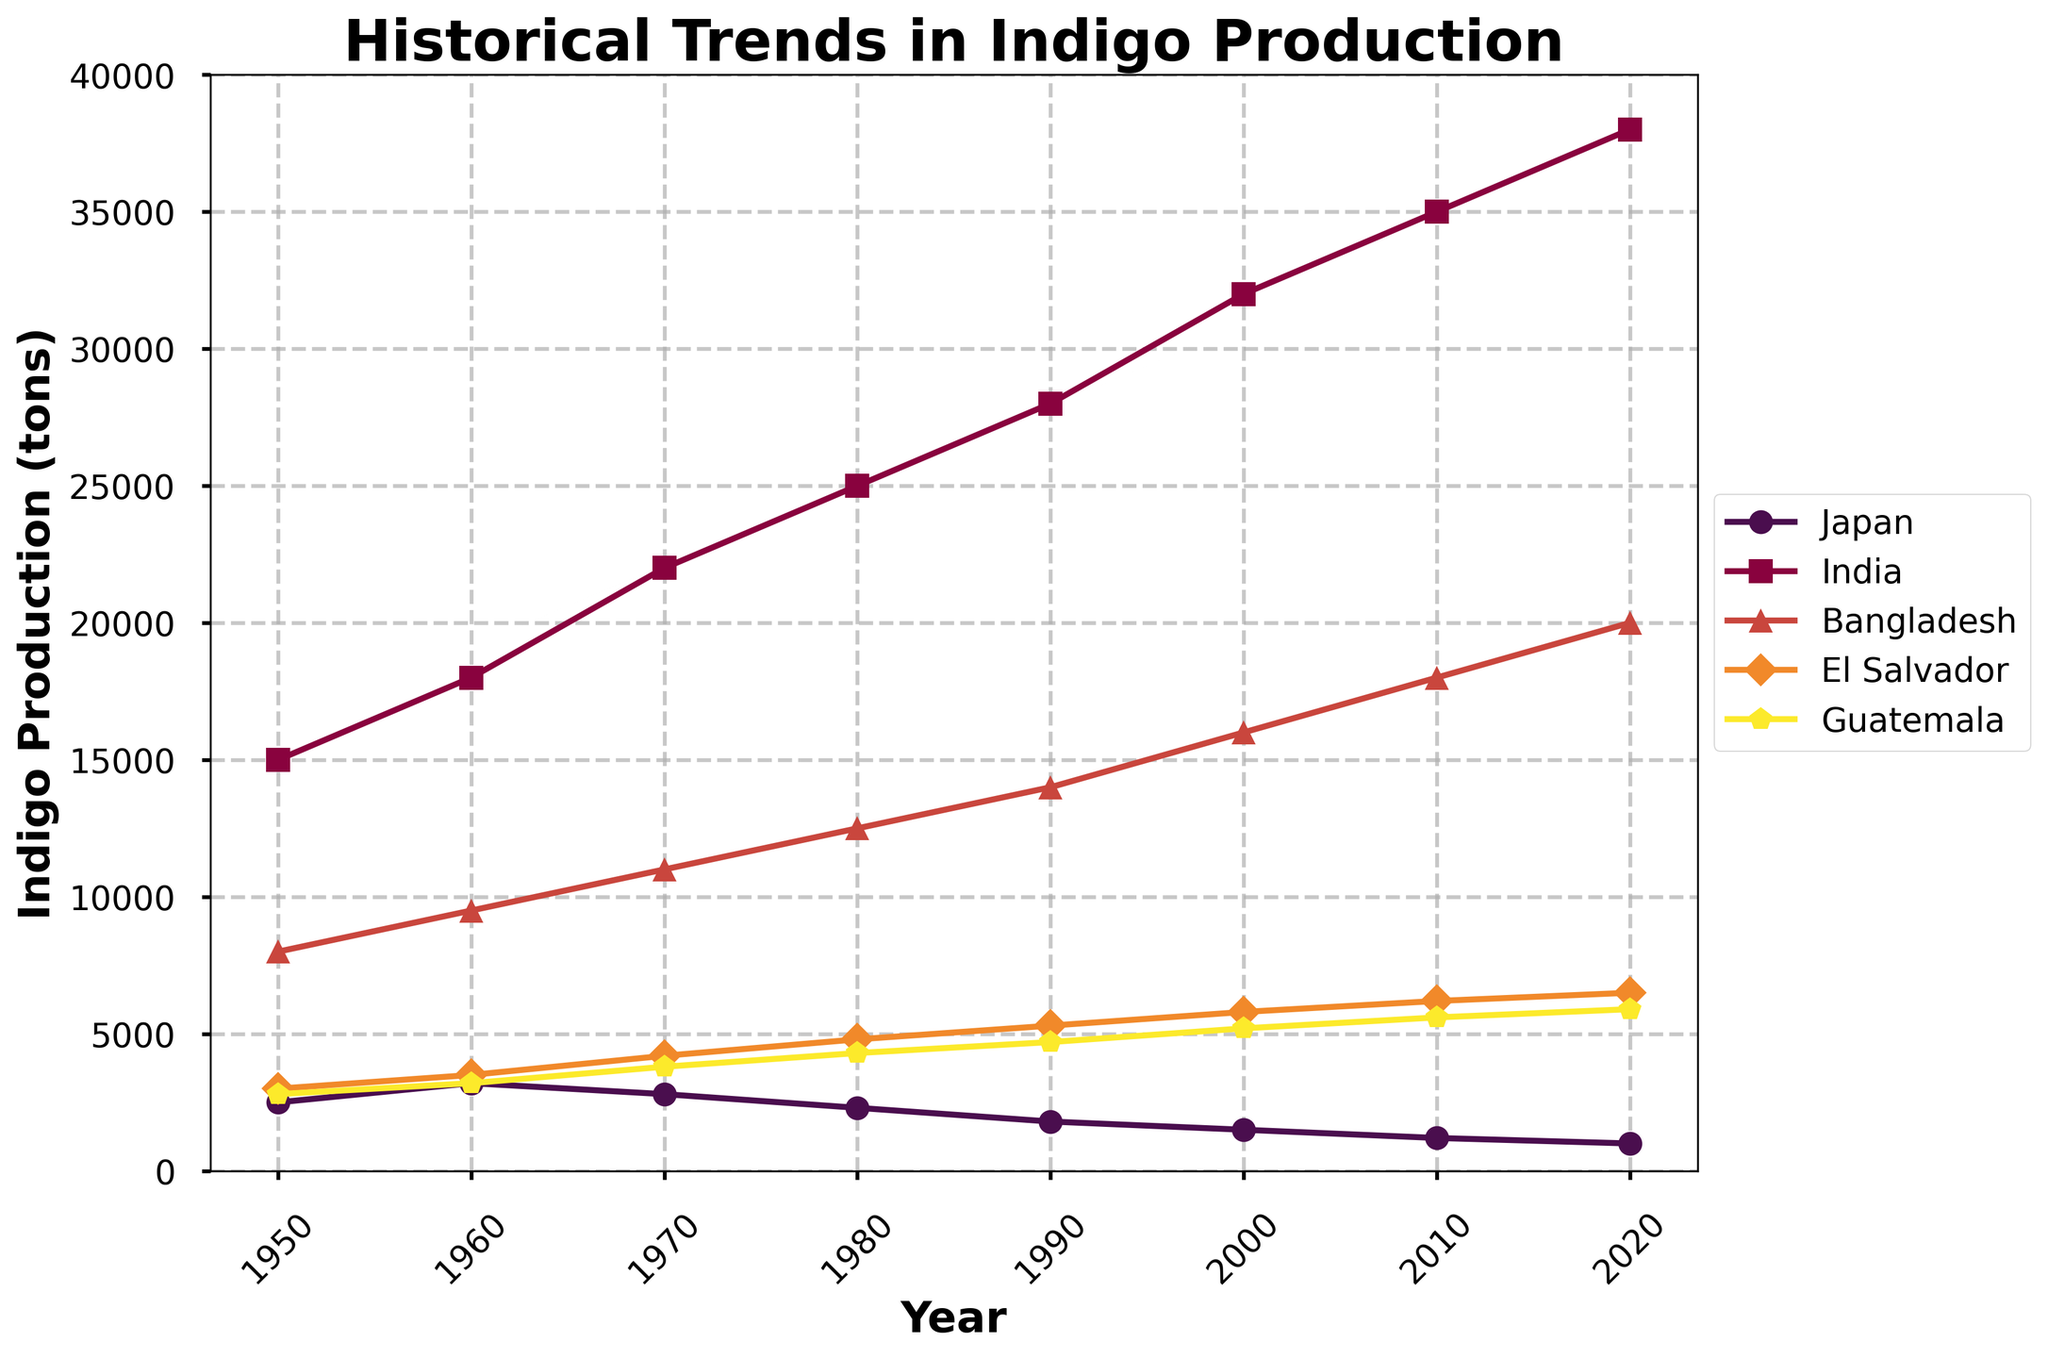What trends can you observe in Japan's indigo production from 1950 to 2020? Japan's indigo production shows a continuous decline from 2500 tons in 1950 to 1000 tons in 2020. This trend indicates a steady decrease over the 70 years.
Answer: Continuous decline How does the indigo production change in India from 1980 to 2020? India's indigo production increases from 25000 tons in 1980 to 38000 tons in 2020, indicating a continuous upward trend over the 40 years.
Answer: Continuous increase In which year does Bangladesh's indigo production reach 16000 tons? From the chart, Bangladesh's indigo production reaches 16000 tons in the year 2000.
Answer: 2000 What is the difference in indigo production between El Salvador and Guatemala in 2020? In 2020, El Salvador's indigo production is 6500 tons, and Guatemala's production is 5900 tons. The difference is 6500 - 5900 = 600 tons.
Answer: 600 tons How does indigo production in Guatemala in 1950 compare to that in 1980? Guatemala's indigo production in 1950 is 2800 tons, and in 1980 it is 4300 tons. Guatemala's production increased by 4300 - 2800 = 1500 tons from 1950 to 1980.
Answer: Increased by 1500 tons Which country had the highest increase in indigo production from 1950 to 2020? From the chart, India had the highest increase, from 15000 tons in 1950 to 38000 tons in 2020, with an increase of 38000 - 15000 = 23000 tons.
Answer: India Is there any year when Japan's indigo production exceeds that of Bangladesh? No, from the chart, it is clear that throughout all the years, Bangladesh's indigo production is always higher than Japan's.
Answer: No Between 1960 and 1980, which country shows the most significant rise in indigo production? Between 1960 and 1980, India shows the most significant rise, from 18000 tons to 25000 tons, an increase of 7000 tons.
Answer: India What visual attributes differentiate El Salvador's indigo production line from that of Guatemala? El Salvador's indigo production line is shown with markers shaped like diamonds ('D') and is colored in an orange tone. In contrast, Guatemala's line has pentagon markers ('p') and is colored in yellow.
Answer: Diamond markers and orange for El Salvador, pentagon markers and yellow for Guatemala Which country had the lowest indigo production in 2020, and what was the amount? In 2020, Japan had the lowest indigo production with 1000 tons.
Answer: Japan, 1000 tons 